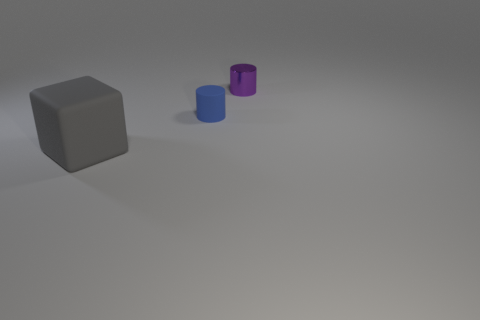Is the material of the tiny cylinder that is behind the tiny matte object the same as the thing in front of the small rubber thing?
Offer a very short reply. No. Are there more tiny blue matte cylinders on the left side of the tiny blue object than small blue rubber cylinders?
Your response must be concise. No. What color is the matte object that is in front of the matte thing behind the large gray block?
Keep it short and to the point. Gray. There is a purple thing that is the same size as the blue cylinder; what shape is it?
Your answer should be compact. Cylinder. Are there an equal number of large objects that are behind the blue rubber thing and large matte things?
Make the answer very short. No. There is a cylinder on the left side of the thing that is behind the cylinder in front of the small purple thing; what is it made of?
Give a very brief answer. Rubber. There is a small object that is made of the same material as the large gray thing; what is its shape?
Give a very brief answer. Cylinder. Are there any other things that have the same color as the small metallic cylinder?
Keep it short and to the point. No. What number of blocks are to the left of the matte thing that is to the right of the large matte object left of the small blue cylinder?
Your response must be concise. 1. How many blue things are either large things or matte objects?
Offer a very short reply. 1. 